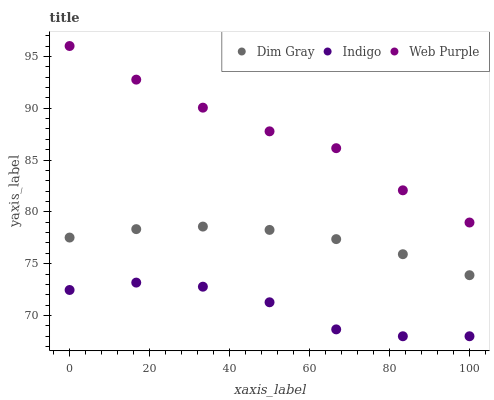Does Indigo have the minimum area under the curve?
Answer yes or no. Yes. Does Web Purple have the maximum area under the curve?
Answer yes or no. Yes. Does Dim Gray have the minimum area under the curve?
Answer yes or no. No. Does Dim Gray have the maximum area under the curve?
Answer yes or no. No. Is Dim Gray the smoothest?
Answer yes or no. Yes. Is Indigo the roughest?
Answer yes or no. Yes. Is Indigo the smoothest?
Answer yes or no. No. Is Dim Gray the roughest?
Answer yes or no. No. Does Indigo have the lowest value?
Answer yes or no. Yes. Does Dim Gray have the lowest value?
Answer yes or no. No. Does Web Purple have the highest value?
Answer yes or no. Yes. Does Dim Gray have the highest value?
Answer yes or no. No. Is Indigo less than Web Purple?
Answer yes or no. Yes. Is Web Purple greater than Dim Gray?
Answer yes or no. Yes. Does Indigo intersect Web Purple?
Answer yes or no. No. 